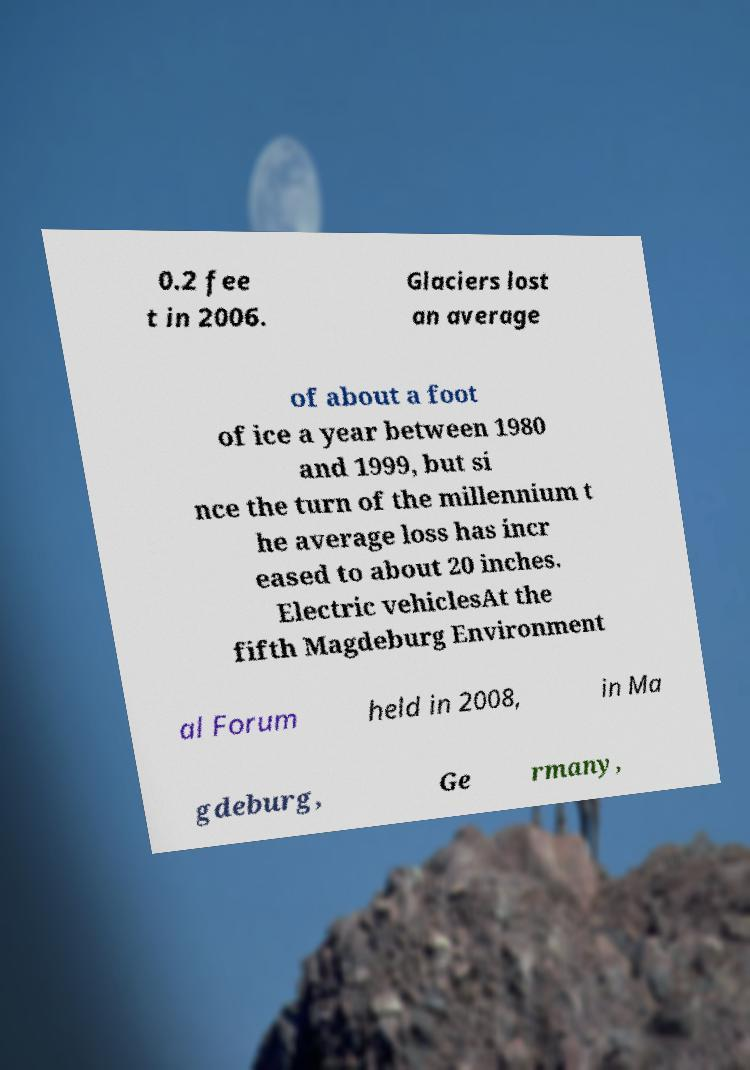There's text embedded in this image that I need extracted. Can you transcribe it verbatim? 0.2 fee t in 2006. Glaciers lost an average of about a foot of ice a year between 1980 and 1999, but si nce the turn of the millennium t he average loss has incr eased to about 20 inches. Electric vehiclesAt the fifth Magdeburg Environment al Forum held in 2008, in Ma gdeburg, Ge rmany, 